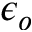Convert formula to latex. <formula><loc_0><loc_0><loc_500><loc_500>\epsilon _ { o }</formula> 